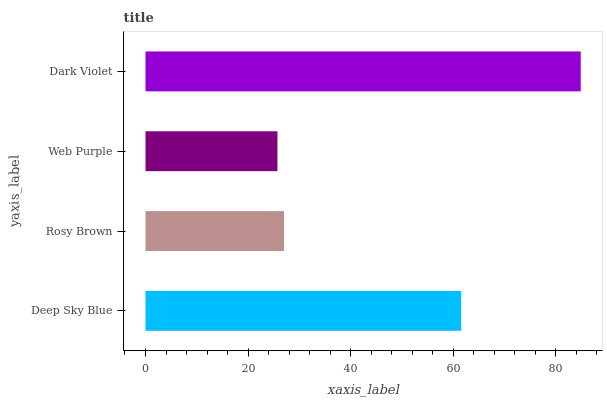Is Web Purple the minimum?
Answer yes or no. Yes. Is Dark Violet the maximum?
Answer yes or no. Yes. Is Rosy Brown the minimum?
Answer yes or no. No. Is Rosy Brown the maximum?
Answer yes or no. No. Is Deep Sky Blue greater than Rosy Brown?
Answer yes or no. Yes. Is Rosy Brown less than Deep Sky Blue?
Answer yes or no. Yes. Is Rosy Brown greater than Deep Sky Blue?
Answer yes or no. No. Is Deep Sky Blue less than Rosy Brown?
Answer yes or no. No. Is Deep Sky Blue the high median?
Answer yes or no. Yes. Is Rosy Brown the low median?
Answer yes or no. Yes. Is Web Purple the high median?
Answer yes or no. No. Is Deep Sky Blue the low median?
Answer yes or no. No. 